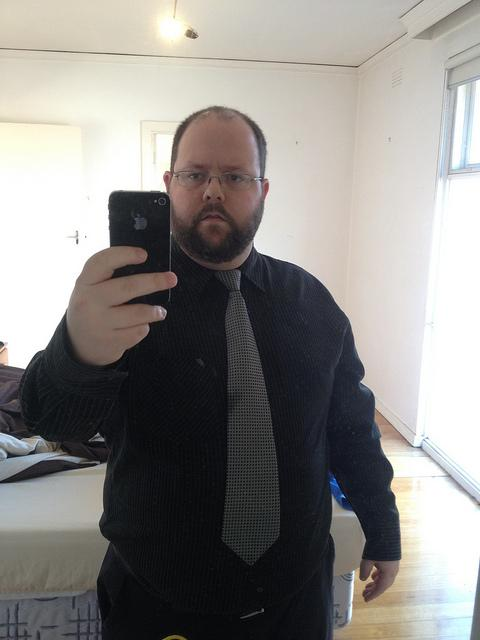What is the man taking?

Choices:
A) selfie
B) karate class
C) online course
D) bar exam selfie 